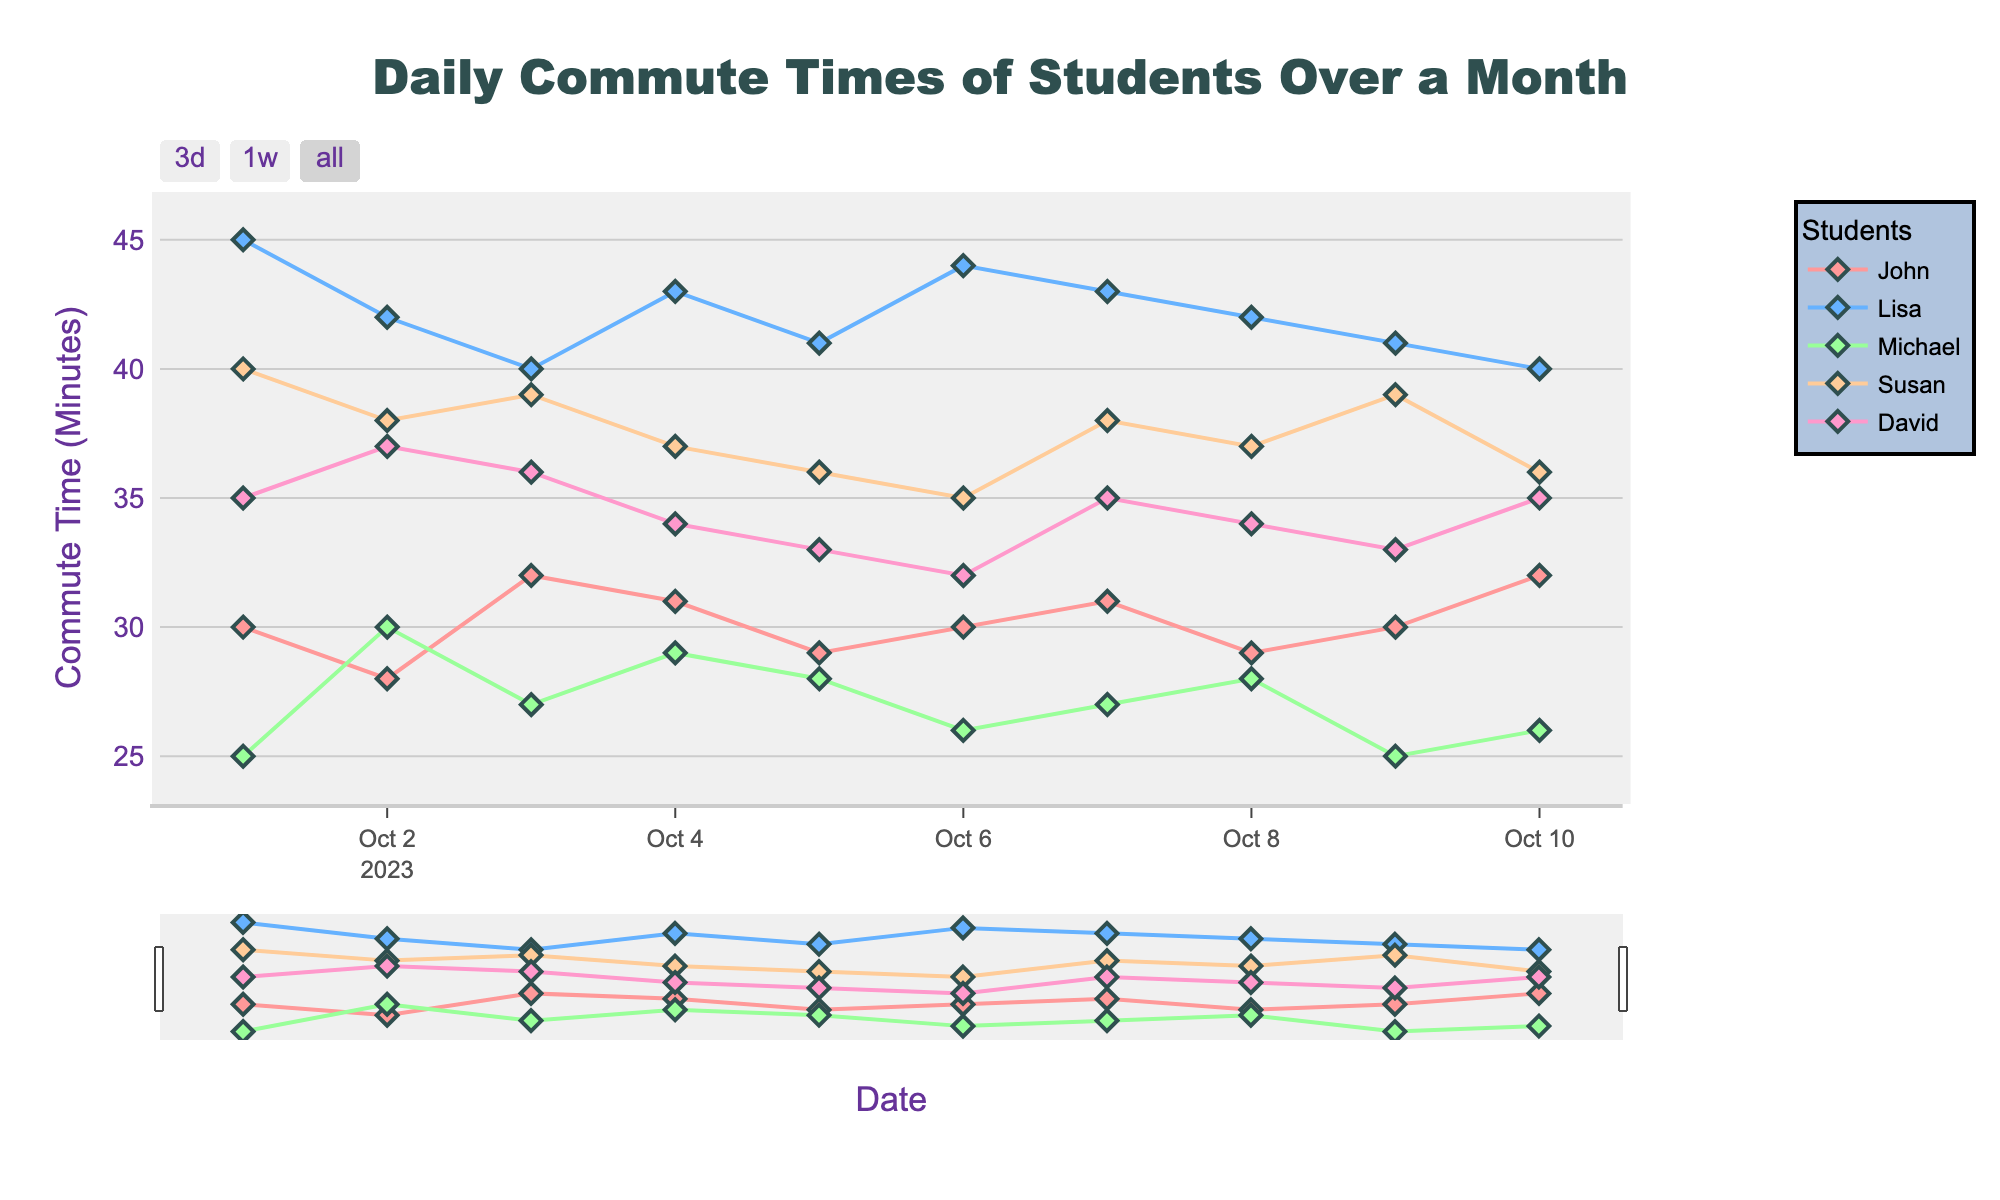What's the title of the figure? The title is usually found at the top of the figure. In this case, it reads "Daily Commute Times of Students Over a Month".
Answer: Daily Commute Times of Students Over a Month What is the y-axis labeled as? The y-axis label can be found on the vertical axis of the plot. Here, it reads "Commute Time (Minutes)".
Answer: Commute Time (Minutes) How many students' data are presented in the plot? The legend shows each student's name, which allows us to count the represented students. There are five unique names listed.
Answer: 5 Which student had the shortest commute time on October 1st? Looking at the figure on the x-axis for October 1st, the lowest point on the y-axis is for Michael. His commute time is 25 minutes.
Answer: Michael What is the average commute time for John over the first five days? John's commute times from October 1st to October 5th are: 30, 28, 32, 31, 29. The sum is 150, and the average is 150/5.
Answer: 30 Who had the most fluctuating commute times over the given dates? By observing the variability of the lines, Lisa appears to have the highest variation in her commute times, ranging between 40 and 45 minutes almost daily.
Answer: Lisa Compare the commute times of John and Lisa on October 3rd. Who had a longer commute? On October 3rd, John's commute time is 32 minutes, while Lisa's is 40 minutes. Therefore, Lisa had a longer commute.
Answer: Lisa What's the trend of David's commute times over the first six days? Observing David's line, we see that his commute time started high, dipped slightly towards the middle, and then decreased gradually over the six days.
Answer: Decreasing During the observed period, what appears to be the consistent trend for Michael's commute times? Michael's line indicates that his commute times are generally stable with minor fluctuations between 25 and 30 minutes.
Answer: Stable How does Susan's commute time on October 6th compare to her commute on October 7th? On October 6th, Susan's commute time is 35 minutes, whereas on October 7th, it is 38 minutes, showing an increase of 3 minutes.
Answer: Increased 